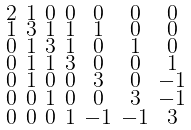<formula> <loc_0><loc_0><loc_500><loc_500>\begin{smallmatrix} 2 & 1 & 0 & 0 & 0 & 0 & 0 \\ 1 & 3 & 1 & 1 & 1 & 0 & 0 \\ 0 & 1 & 3 & 1 & 0 & 1 & 0 \\ 0 & 1 & 1 & 3 & 0 & 0 & 1 \\ 0 & 1 & 0 & 0 & 3 & 0 & - 1 \\ 0 & 0 & 1 & 0 & 0 & 3 & - 1 \\ 0 & 0 & 0 & 1 & - 1 & - 1 & 3 \end{smallmatrix}</formula> 